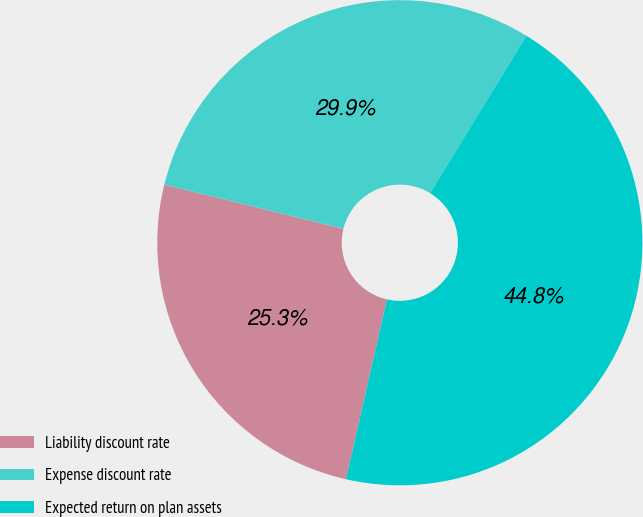Convert chart. <chart><loc_0><loc_0><loc_500><loc_500><pie_chart><fcel>Liability discount rate<fcel>Expense discount rate<fcel>Expected return on plan assets<nl><fcel>25.29%<fcel>29.89%<fcel>44.83%<nl></chart> 